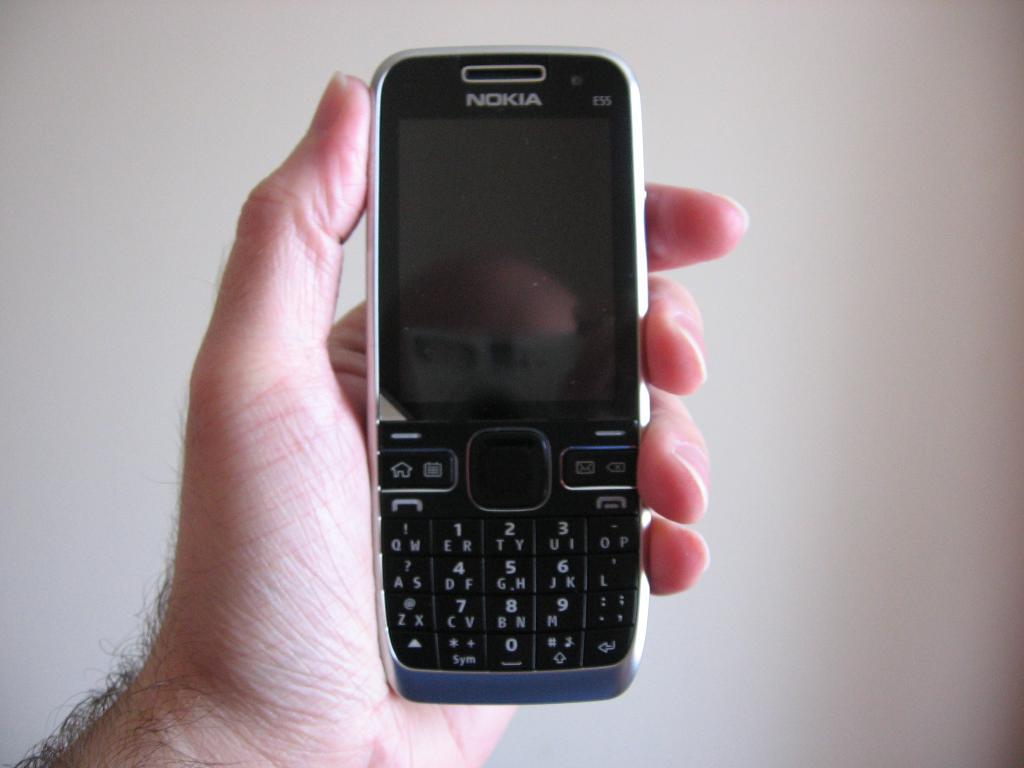What brand of cell phone is being held?
Your answer should be very brief. Nokia. What is the name of the phone?
Make the answer very short. Nokia. 